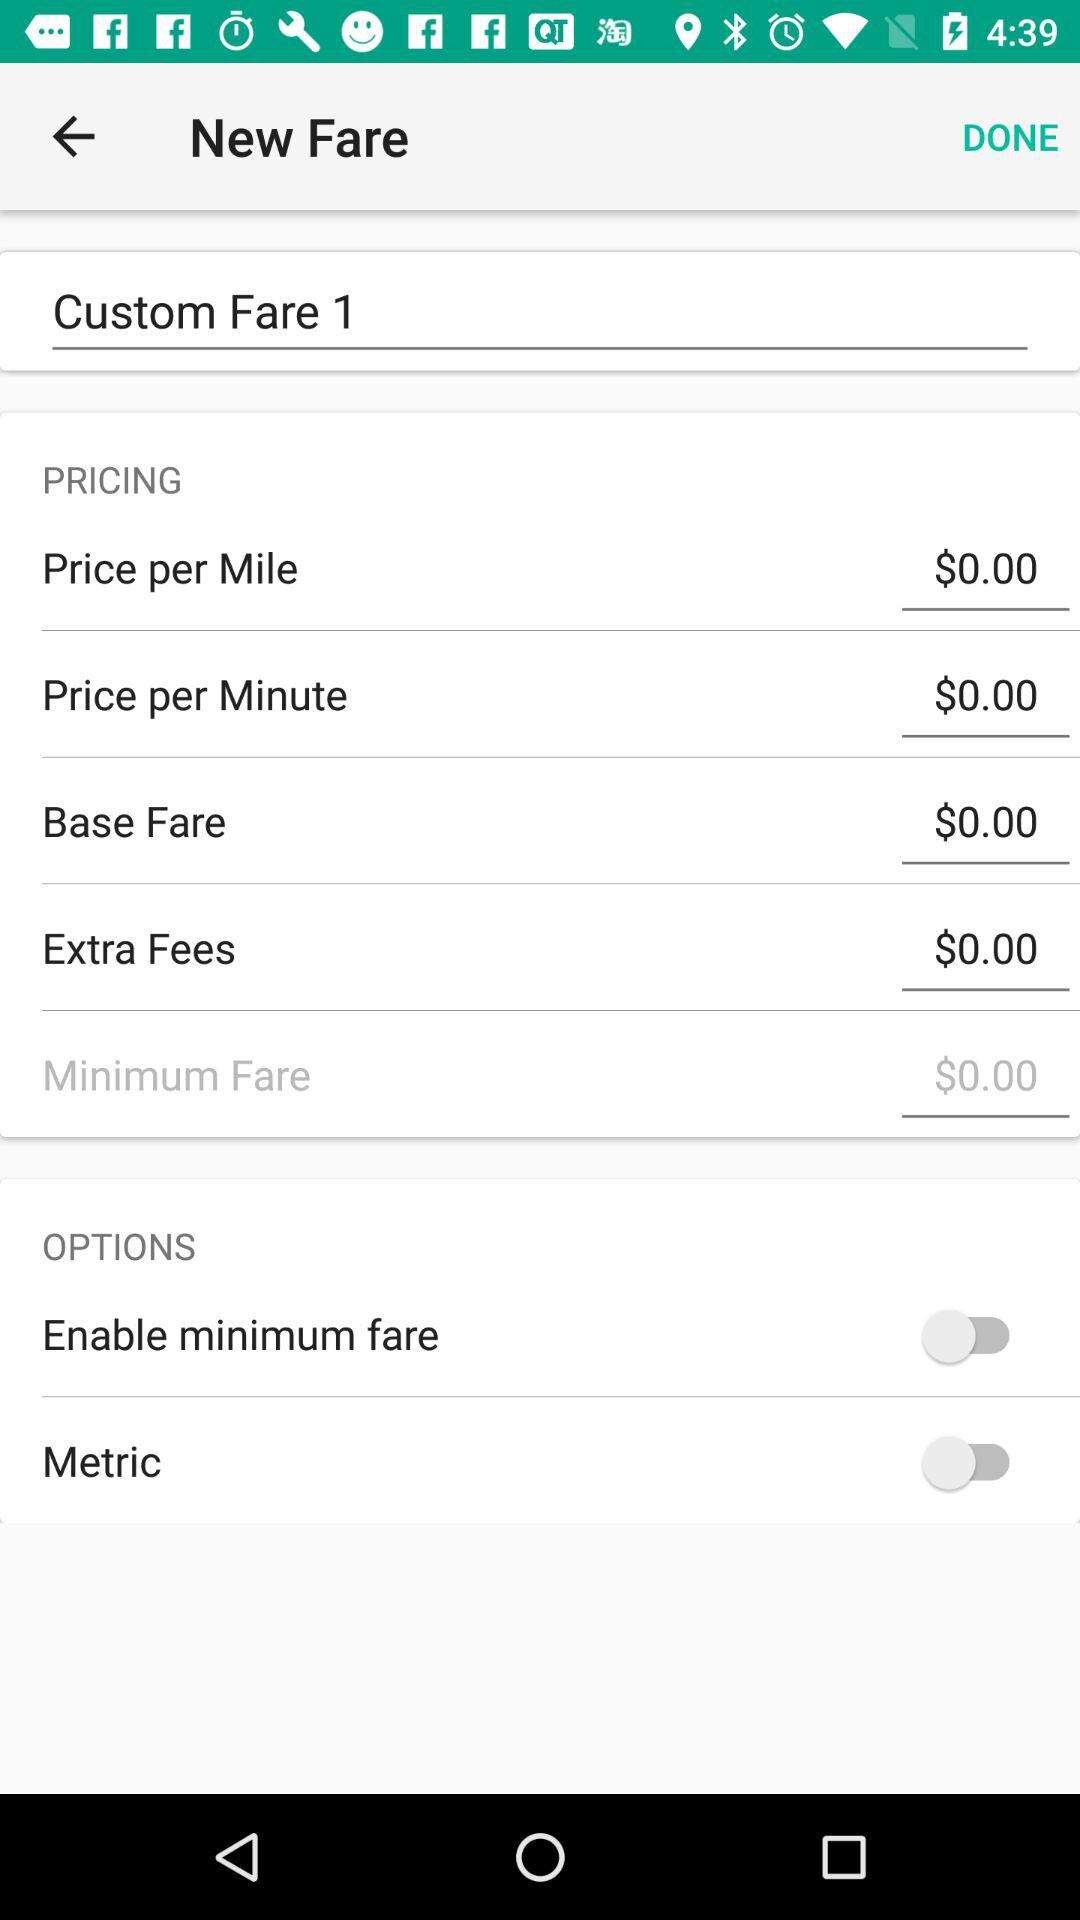How much is the price per mile? The price per mile is $0.00. 